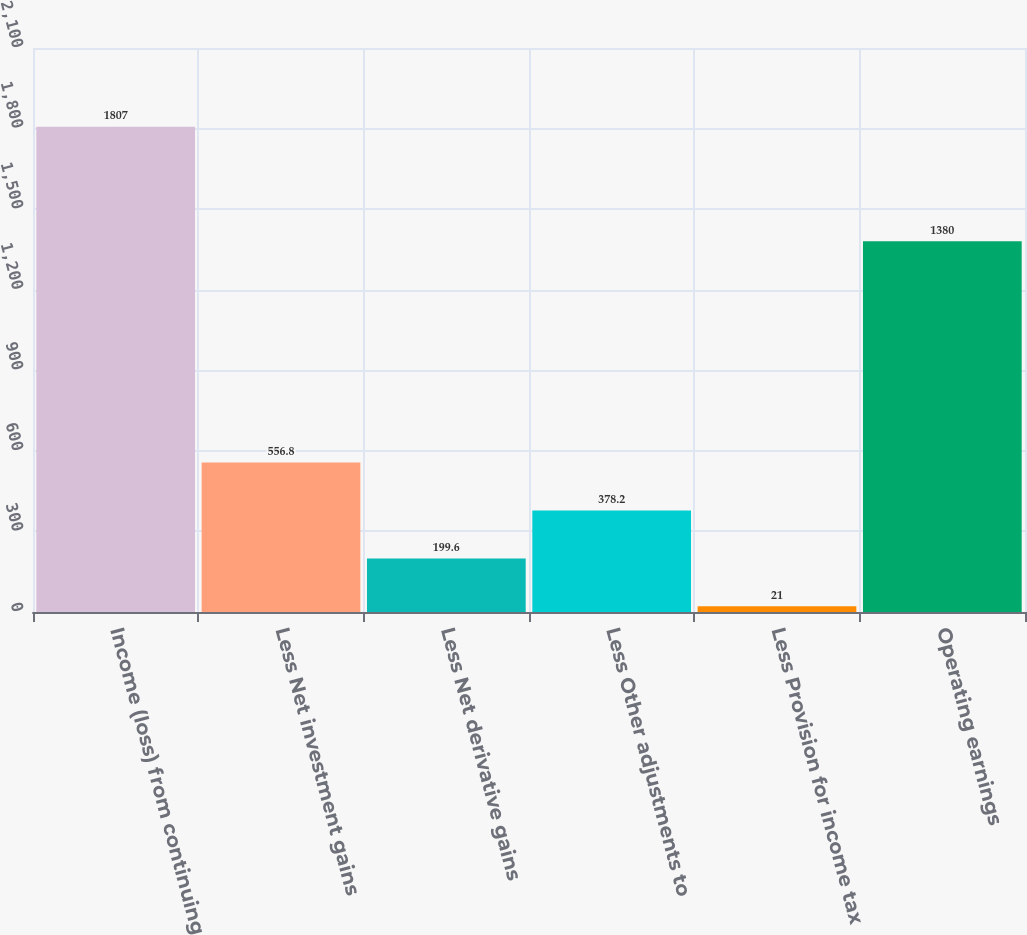<chart> <loc_0><loc_0><loc_500><loc_500><bar_chart><fcel>Income (loss) from continuing<fcel>Less Net investment gains<fcel>Less Net derivative gains<fcel>Less Other adjustments to<fcel>Less Provision for income tax<fcel>Operating earnings<nl><fcel>1807<fcel>556.8<fcel>199.6<fcel>378.2<fcel>21<fcel>1380<nl></chart> 